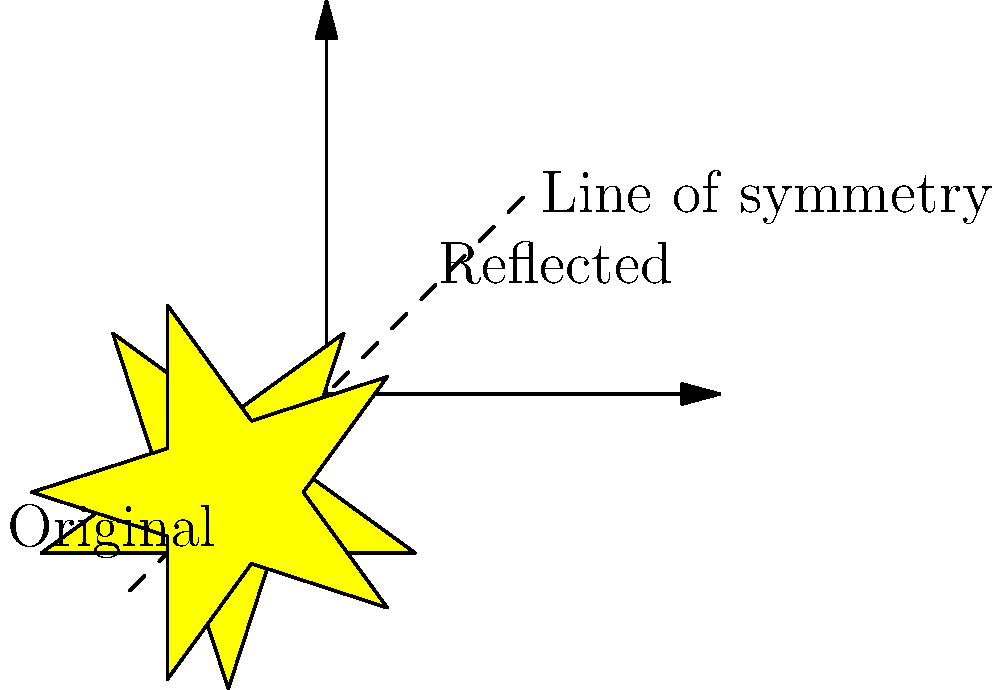"Well, here's another fine mess you've gotten me into!" As Laurel said to Hardy, we find ourselves reflecting on a Hollywood Walk of Fame star. If we reflect the star across the given line of symmetry, what transformation would describe the movement from the original star to its reflection? Let's break this down step-by-step, as if we're dissecting a classic film:

1) First, observe the original star and its reflected counterpart. They are on opposite sides of the dashed line.

2) The dashed line is labeled as the "Line of symmetry". In geometry, when we reflect a shape across a line, this line is called the line of reflection or axis of symmetry.

3) The reflection process creates a mirror image of the original shape on the opposite side of the line of symmetry. Each point of the original shape is mapped to a point that is equidistant from the line of symmetry on the opposite side.

4) This type of transformation, where a shape is flipped over a line to create a mirror image, is known as a reflection.

5) In the context of transformational geometry, a reflection is an isometry, meaning it preserves the size and shape of the original figure.

6) The line of symmetry in this case is diagonal, running from the bottom-left to the top-right of the coordinate plane. This means the reflection will flip the star diagonally.

7) After the reflection, we can see that the star has indeed been flipped diagonally, with its position changed but its size and shape preserved.

Therefore, the transformation that describes the movement from the original star to its new position is a reflection.
Answer: Reflection 